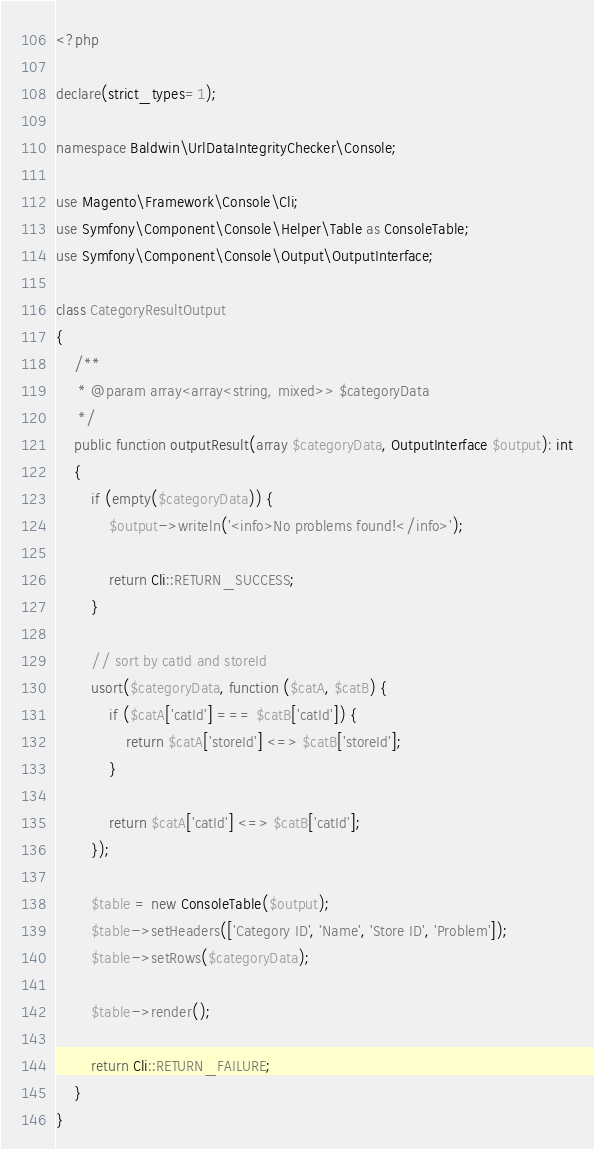Convert code to text. <code><loc_0><loc_0><loc_500><loc_500><_PHP_><?php

declare(strict_types=1);

namespace Baldwin\UrlDataIntegrityChecker\Console;

use Magento\Framework\Console\Cli;
use Symfony\Component\Console\Helper\Table as ConsoleTable;
use Symfony\Component\Console\Output\OutputInterface;

class CategoryResultOutput
{
    /**
     * @param array<array<string, mixed>> $categoryData
     */
    public function outputResult(array $categoryData, OutputInterface $output): int
    {
        if (empty($categoryData)) {
            $output->writeln('<info>No problems found!</info>');

            return Cli::RETURN_SUCCESS;
        }

        // sort by catId and storeId
        usort($categoryData, function ($catA, $catB) {
            if ($catA['catId'] === $catB['catId']) {
                return $catA['storeId'] <=> $catB['storeId'];
            }

            return $catA['catId'] <=> $catB['catId'];
        });

        $table = new ConsoleTable($output);
        $table->setHeaders(['Category ID', 'Name', 'Store ID', 'Problem']);
        $table->setRows($categoryData);

        $table->render();

        return Cli::RETURN_FAILURE;
    }
}
</code> 